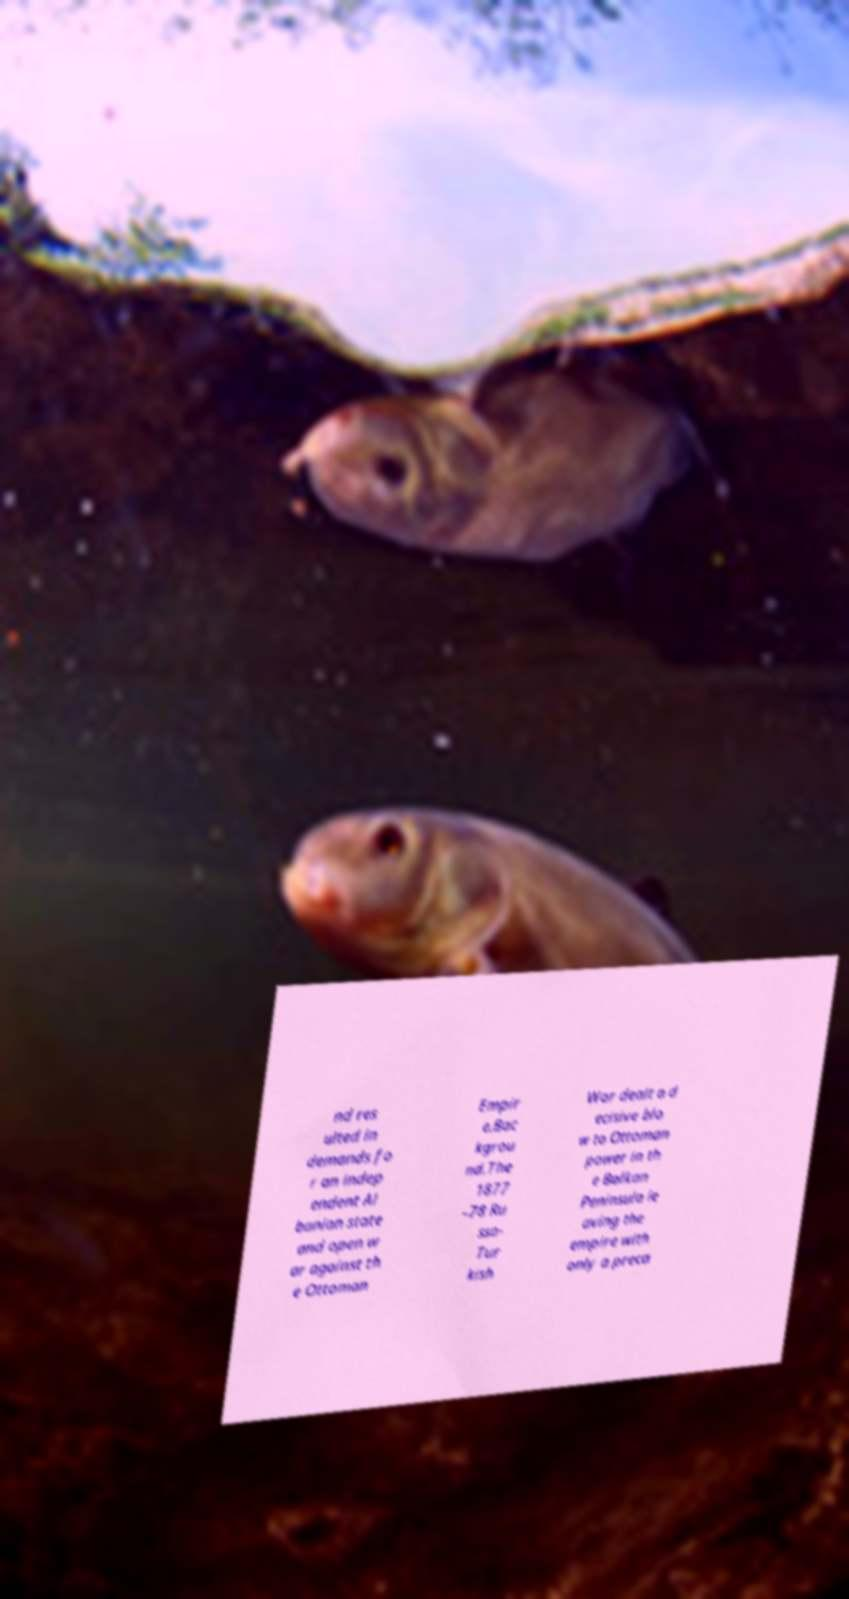Please read and relay the text visible in this image. What does it say? nd res ulted in demands fo r an indep endent Al banian state and open w ar against th e Ottoman Empir e.Bac kgrou nd.The 1877 –78 Ru sso- Tur kish War dealt a d ecisive blo w to Ottoman power in th e Balkan Peninsula le aving the empire with only a preca 